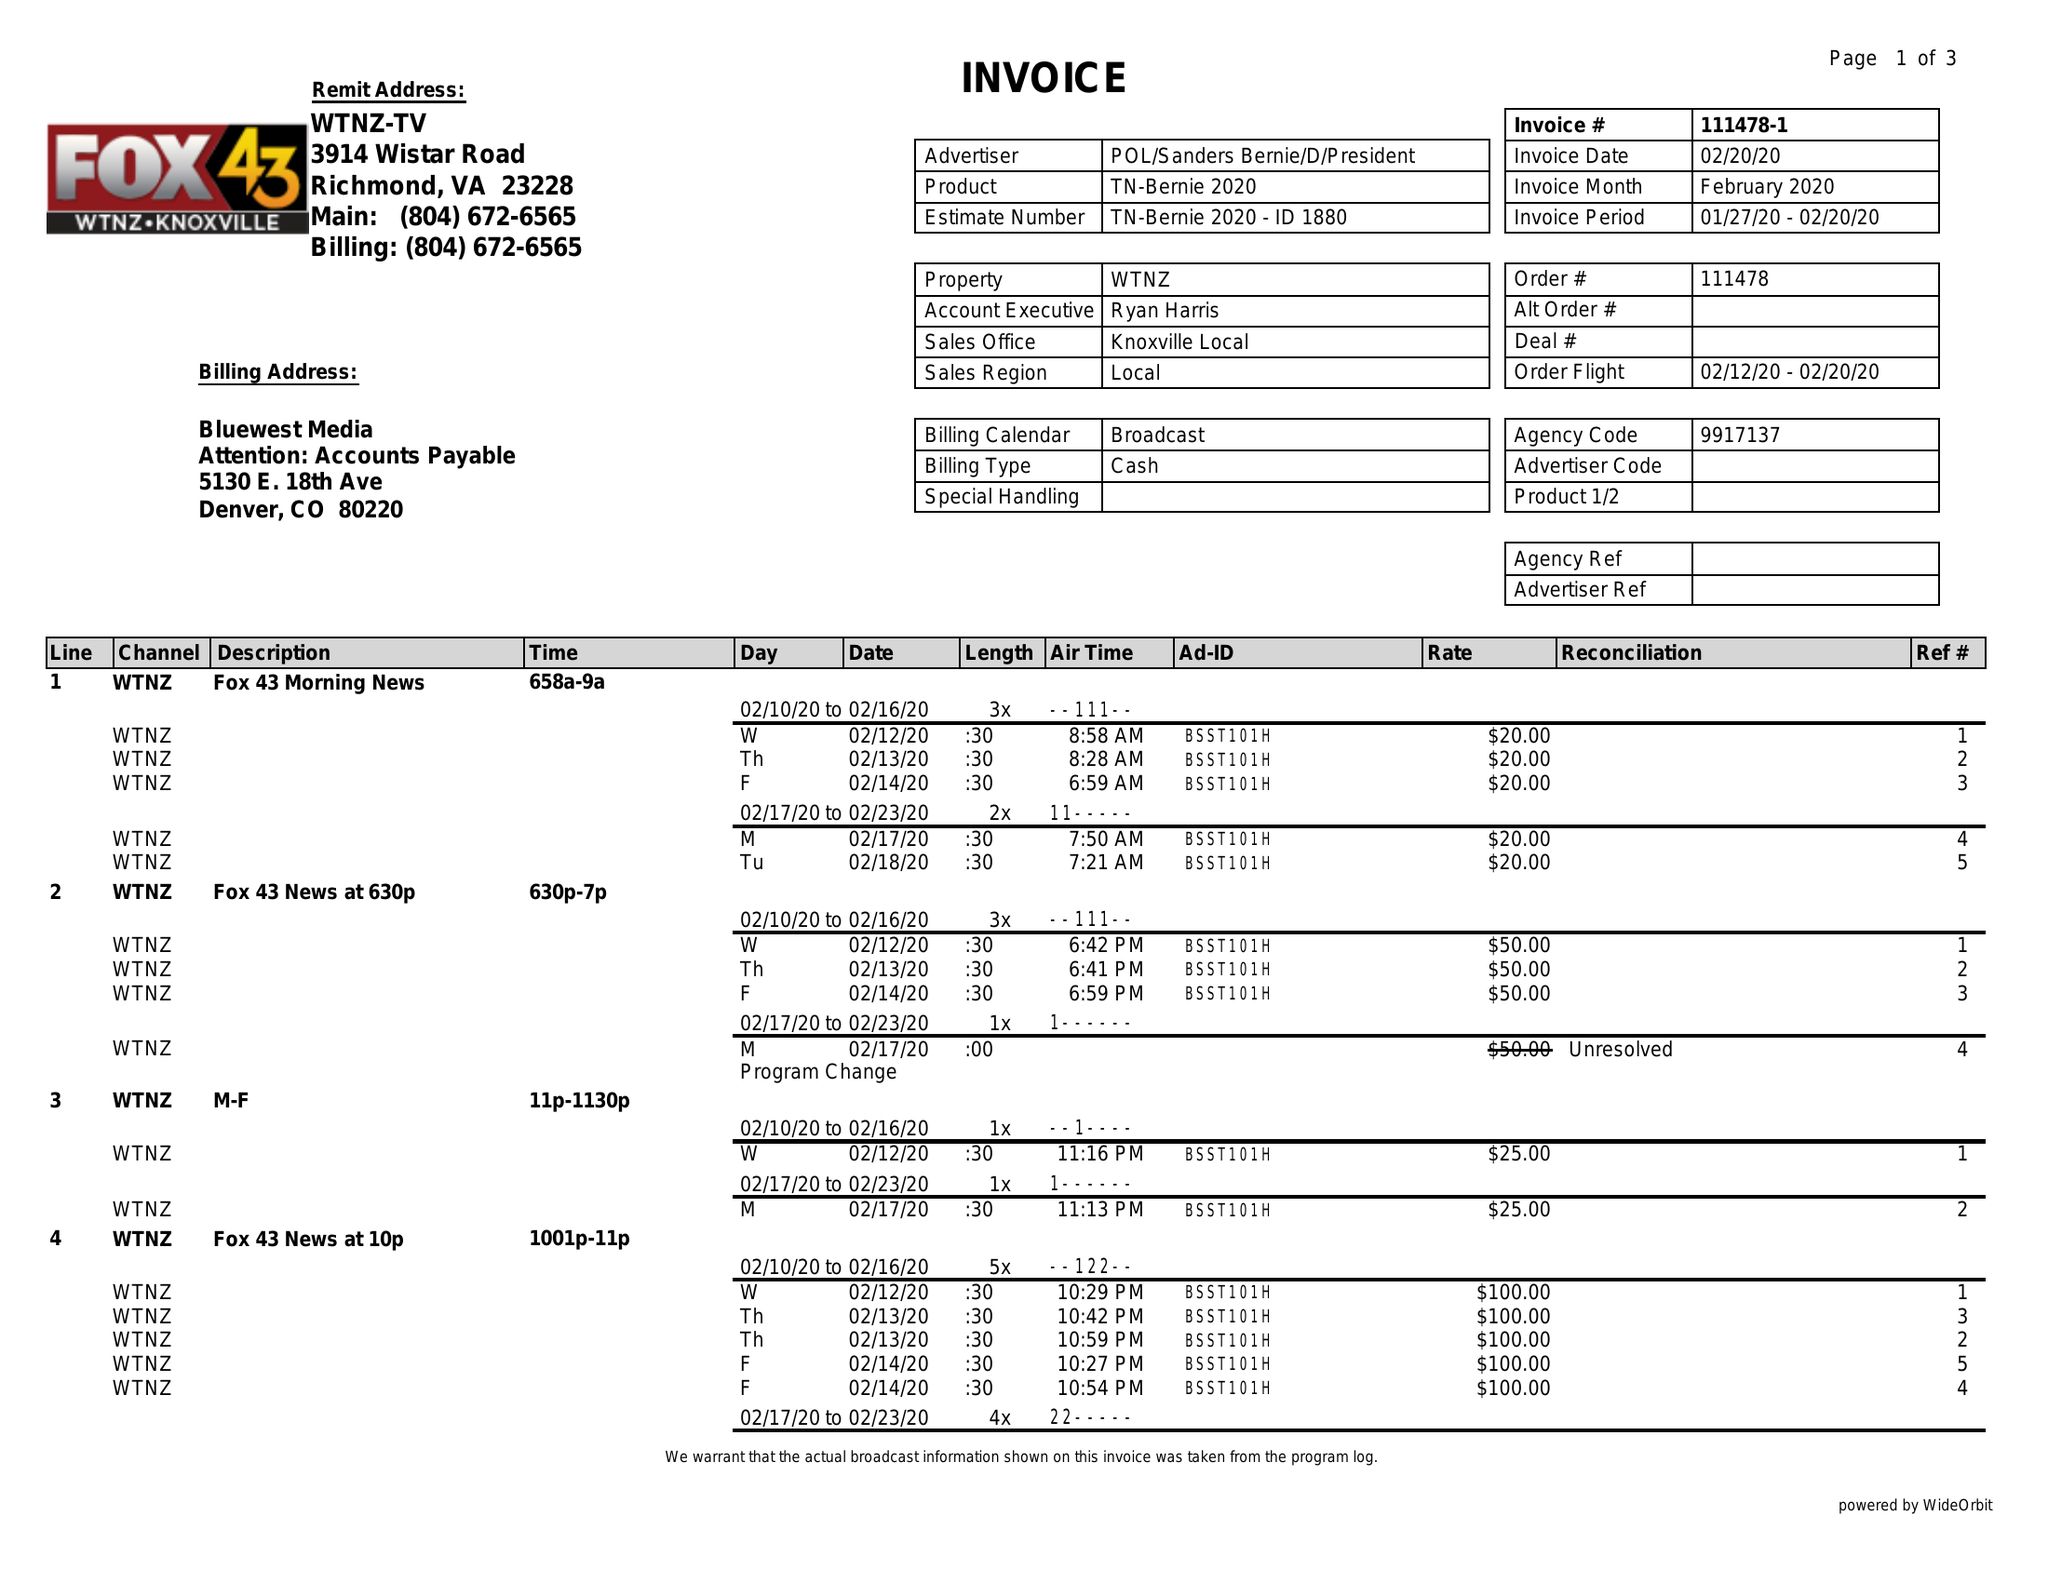What is the value for the flight_to?
Answer the question using a single word or phrase. 02/20/20 